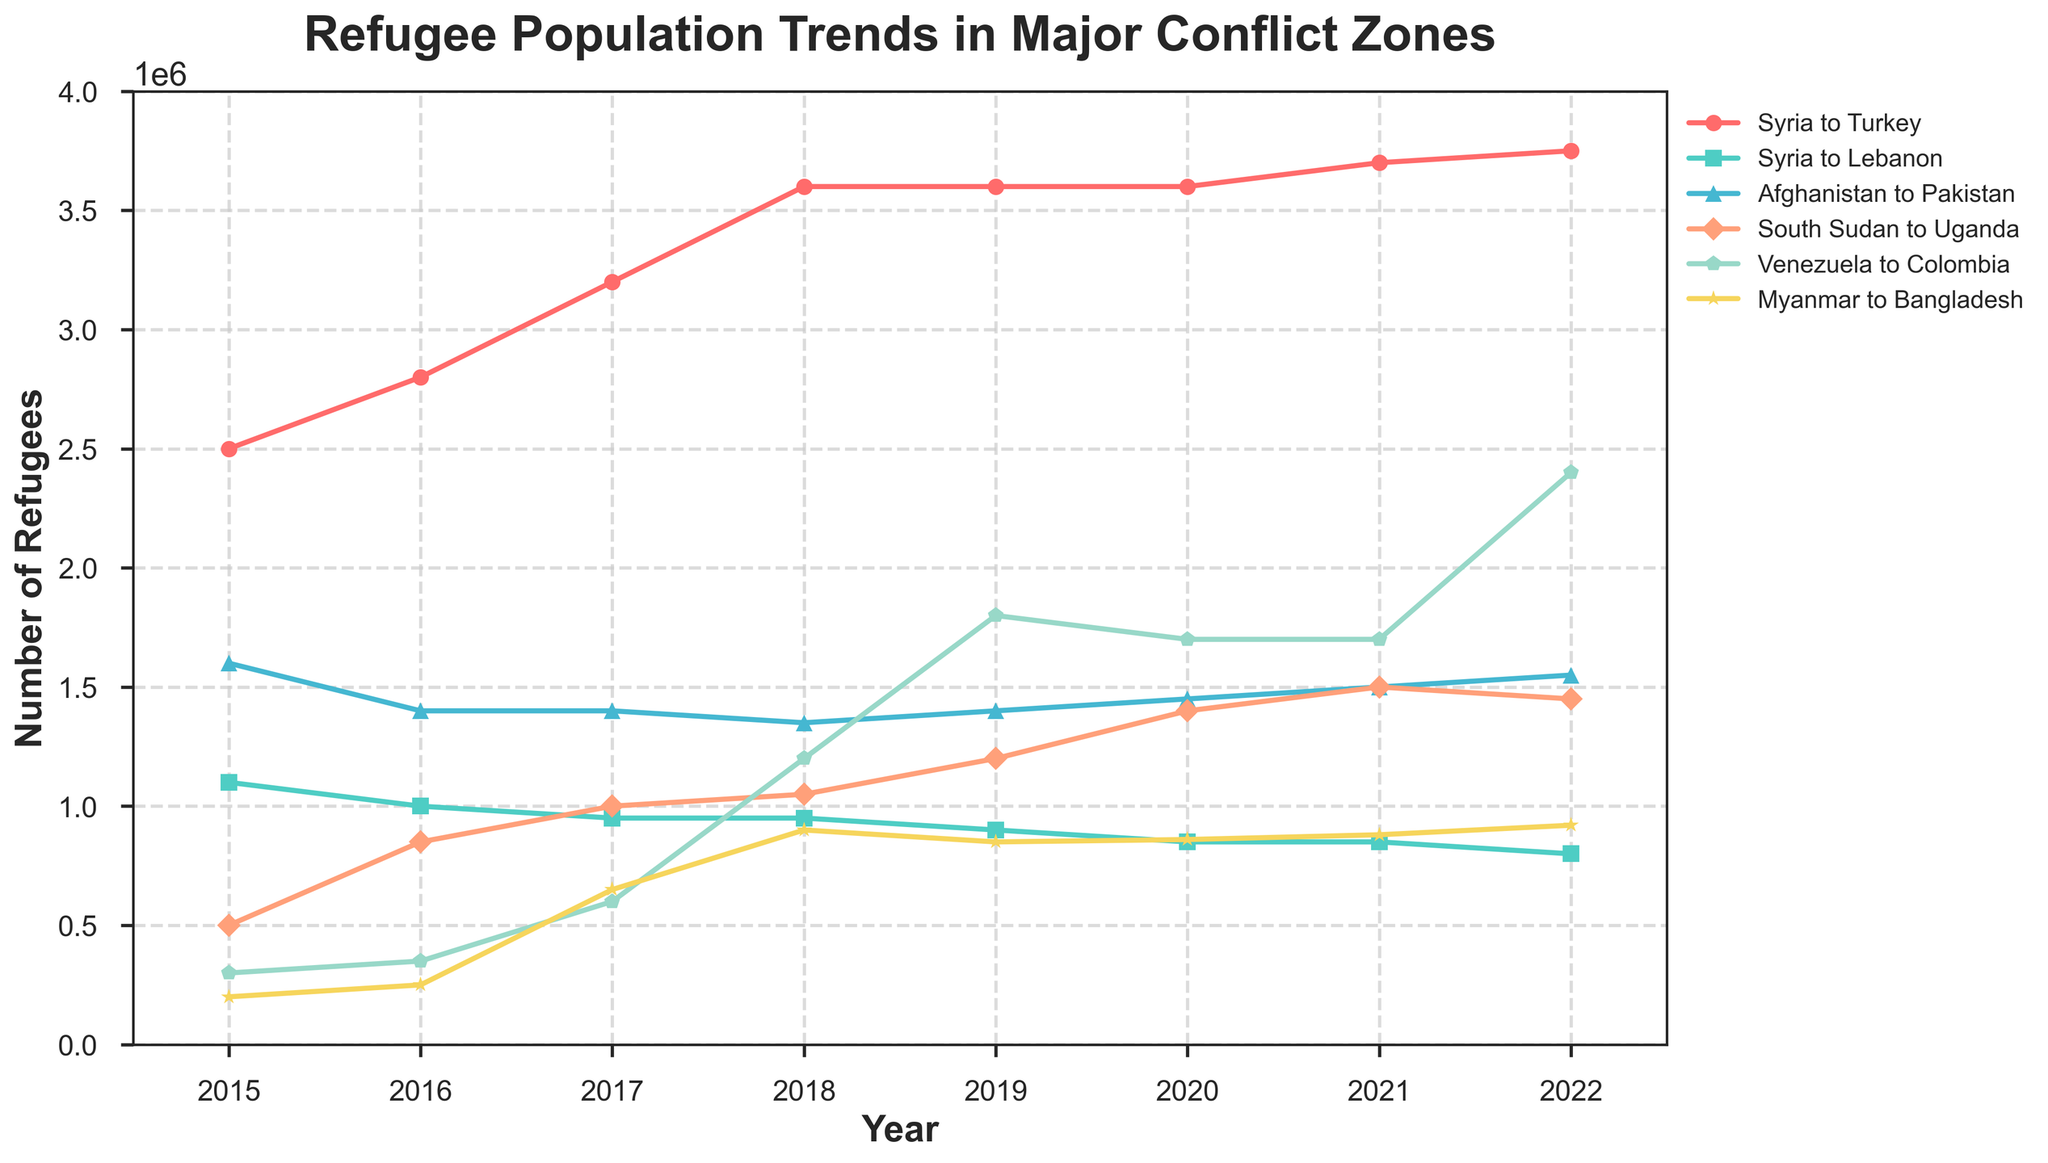Which country has seen the largest increase in the number of refugees from January 2015 to December 2022? To find the country with the largest increase, examine the beginning and ending values for each country across the years. The increase for Syria to Turkey is 3750000 - 2500000 = 1250000. The increases for the other routes are also calculated: Syria to Lebanon (800000 - 1100000 = -300000), Afghanistan to Pakistan (1550000 - 1600000 = -50000), South Sudan to Uganda (1450000 - 500000 = 950000), Venezuela to Colombia (2400000 - 300000 = 2100000), Myanmar to Bangladesh (920000 - 200000 = 720000). The largest increase is for the route from Venezuela to Colombia, with an increase of 2100000.
Answer: Venezuela to Colombia What is the average number of refugees from Syria to Turkey across all observed years? To find the average, add the number of refugees for each year (2500000 + 2800000 + 3200000 + 3600000 + 3600000 + 3600000 + 3700000 + 3750000) and then divide by the number of years, which is 8. The total is 26700000 and the average is 26700000 / 8 = 3337500.
Answer: 3337500 Which year showed the highest number of refugees from Venezuela to Colombia? By examining the plot, the highest point on the line representing Venezuela to Colombia refugees is in 2022 with 2400000 refugees.
Answer: 2022 Compare the refugee trends from South Sudan to Uganda and Myanmar to Bangladesh in 2018. Which one had more refugees, and by how much? According to the plotted data for 2018, South Sudan to Uganda saw 1050000 refugees, while Myanmar to Bangladesh had 900000 refugees. To find the difference, subtract 900000 from 1050000, which equals 150000. Therefore, South Sudan to Uganda had 150000 more refugees than Myanmar to Bangladesh in 2018.
Answer: South Sudan to Uganda by 150000 Which line uses a solid square marker and how many refugees does it represent in 2017? By looking at the markers in the plot, the solid square marker corresponds to Syria to Lebanon. In 2017, the number of refugees for this route is 950000.
Answer: Syria to Lebanon, 950000 